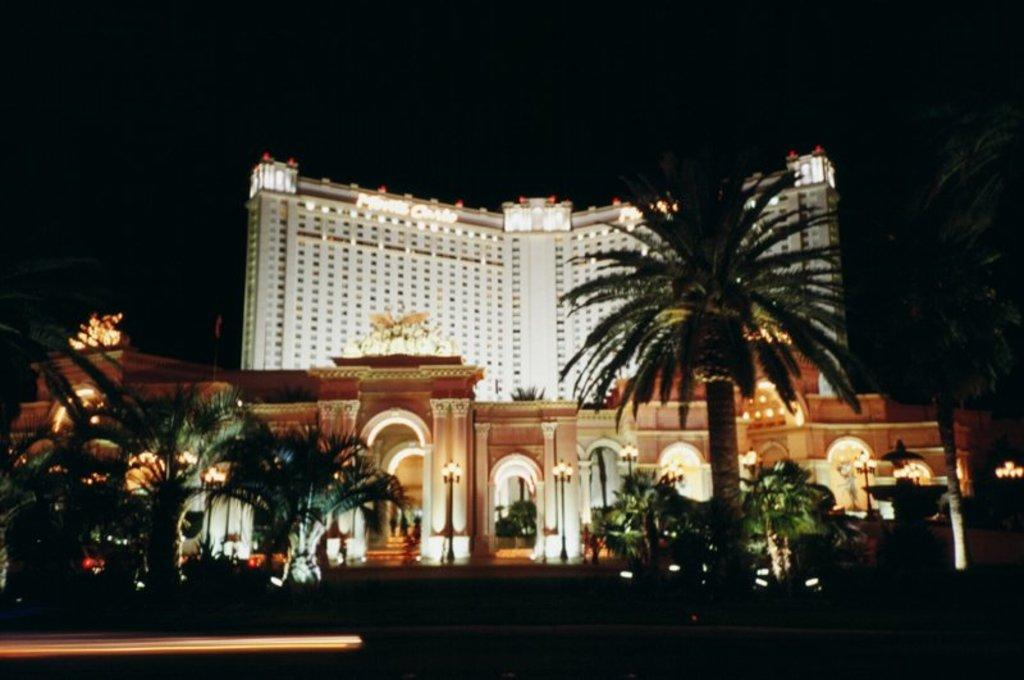What type of building is shown in the image? The image depicts a night view of a hotel. How many floors does the hotel have? The hotel has multiple floors. What architectural features can be seen on the hotel? The hotel has pillars. Are there any lighting features on the hotel? Yes, the hotel has lights. What is the surrounding environment of the hotel? The hotel is surrounded by trees and plants. What is the color of the sky in the image? The sky is dark in the image. Can you see any veins in the image? There are no veins visible in the image, as veins are not a part of buildings or the surrounding environment. --- Facts: 1. There is a person sitting on a chair in the image. 2. The person is holding a book. 3. The book has a blue cover. 4. The chair is made of wood. 5. There is a table next to the chair. Absurd Topics: elephant, ocean, volcano Conversation: What is the person in the image doing? The person is sitting on a chair in the image. What is the person holding in the image? The person is holding a book in the image. What color is the book's cover? The book has a blue cover. What material is the chair made of? The chair is made of wood. What is located next to the chair in the image? There is a table next to the chair in the image. Reasoning: Let's think step by step in order to produce the conversation. We start by identifying the main subject of the image, which is a person sitting on a chair. Then, we describe what the person is holding, which is a book. Next, we mention the color of the book's cover, which is blue. We then describe the material of the chair, which is wood. Finally, we mention the presence of a table next to the chair. Absurd Question/Answer: Can you see an elephant swimming in the ocean in the image? There is no elephant or ocean present in the image. 